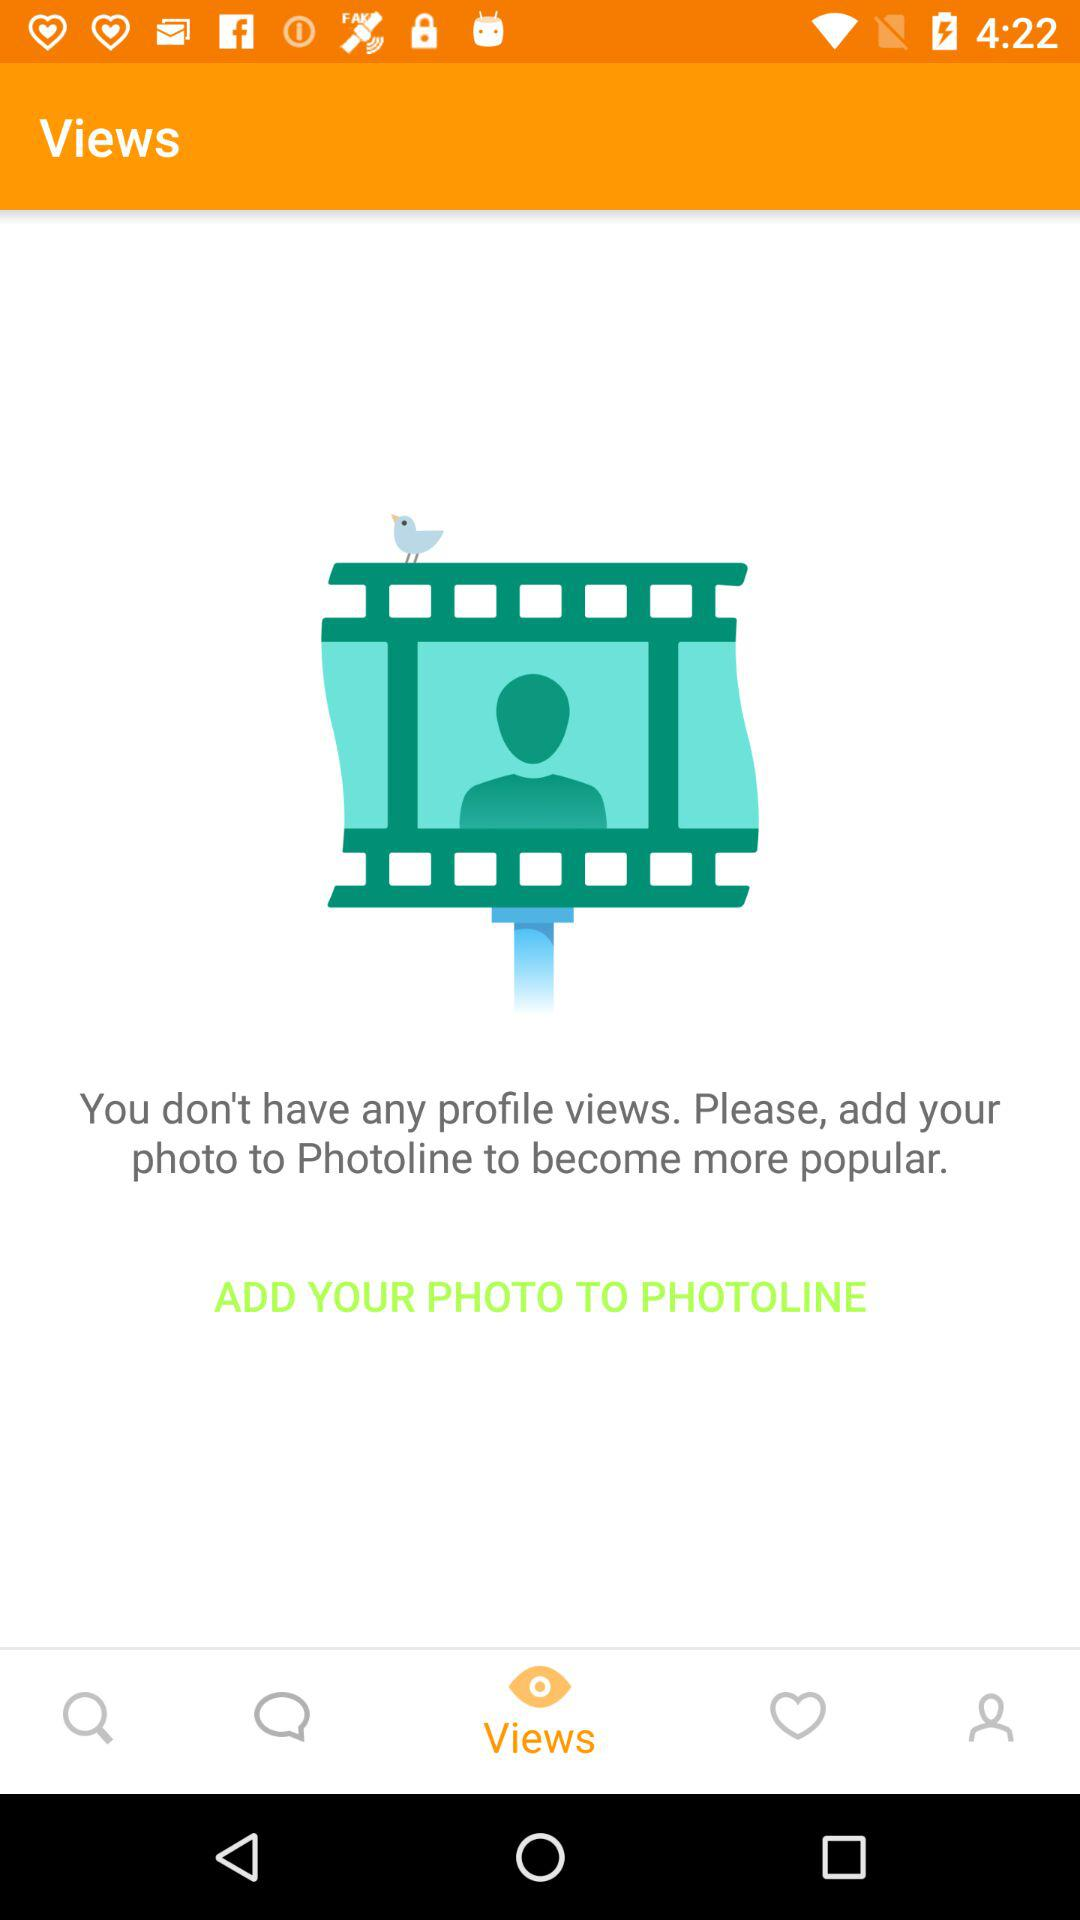Are there any profile views? You don't have any profile views. 